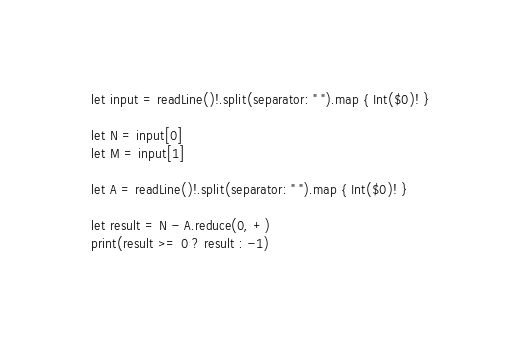Convert code to text. <code><loc_0><loc_0><loc_500><loc_500><_Swift_>let input = readLine()!.split(separator: " ").map { Int($0)! }

let N = input[0]
let M = input[1]

let A = readLine()!.split(separator: " ").map { Int($0)! }

let result = N - A.reduce(0, +)
print(result >= 0 ? result : -1)
</code> 